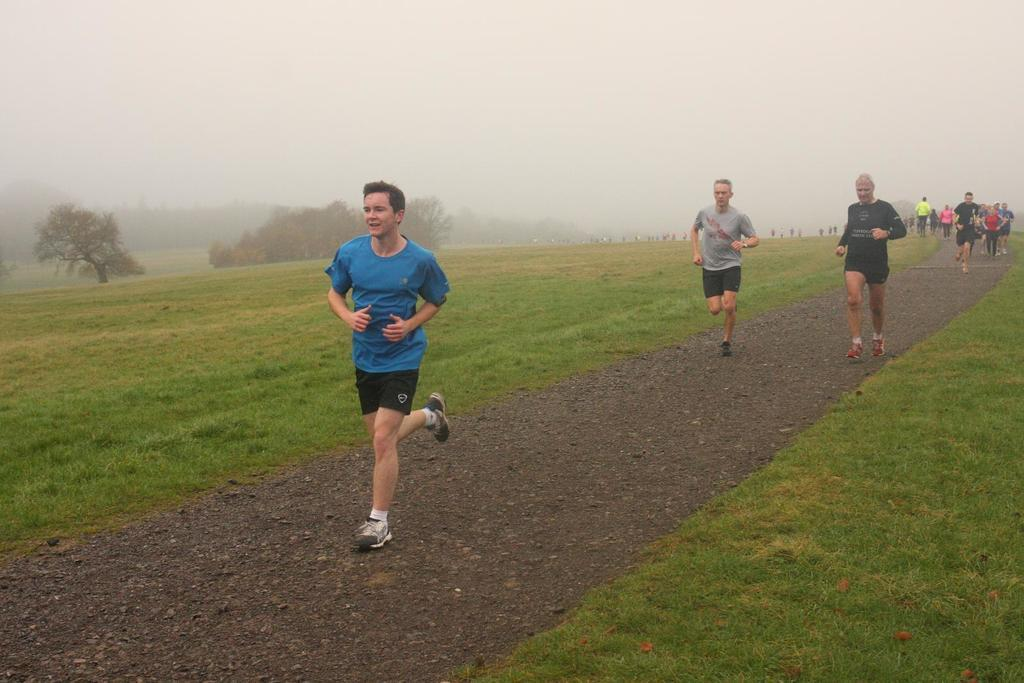What is happening with the groups of people in the image? The people are running on a pathway in the image. What type of terrain can be seen in the image? There is grass visible in the image. Are there any natural elements present in the image? Yes, there are trees in the image. Can you describe the weather condition in the image? The presence of fog is uncertain, as it is only mentioned as a possibility. What type of plastic is being used by the fireman in the image? There is no fireman or plastic present in the image. What sound can be heard from the bells in the image? There are no bells present in the image. 